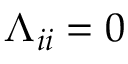Convert formula to latex. <formula><loc_0><loc_0><loc_500><loc_500>\Lambda _ { i i } = 0</formula> 